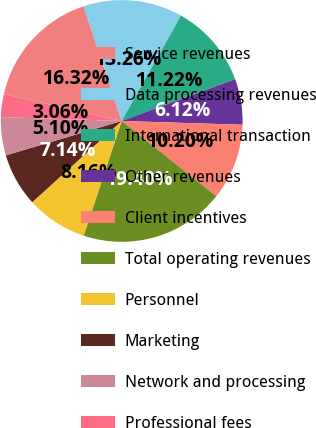Convert chart. <chart><loc_0><loc_0><loc_500><loc_500><pie_chart><fcel>Service revenues<fcel>Data processing revenues<fcel>International transaction<fcel>Other revenues<fcel>Client incentives<fcel>Total operating revenues<fcel>Personnel<fcel>Marketing<fcel>Network and processing<fcel>Professional fees<nl><fcel>16.32%<fcel>13.26%<fcel>11.22%<fcel>6.12%<fcel>10.2%<fcel>19.39%<fcel>8.16%<fcel>7.14%<fcel>5.1%<fcel>3.06%<nl></chart> 